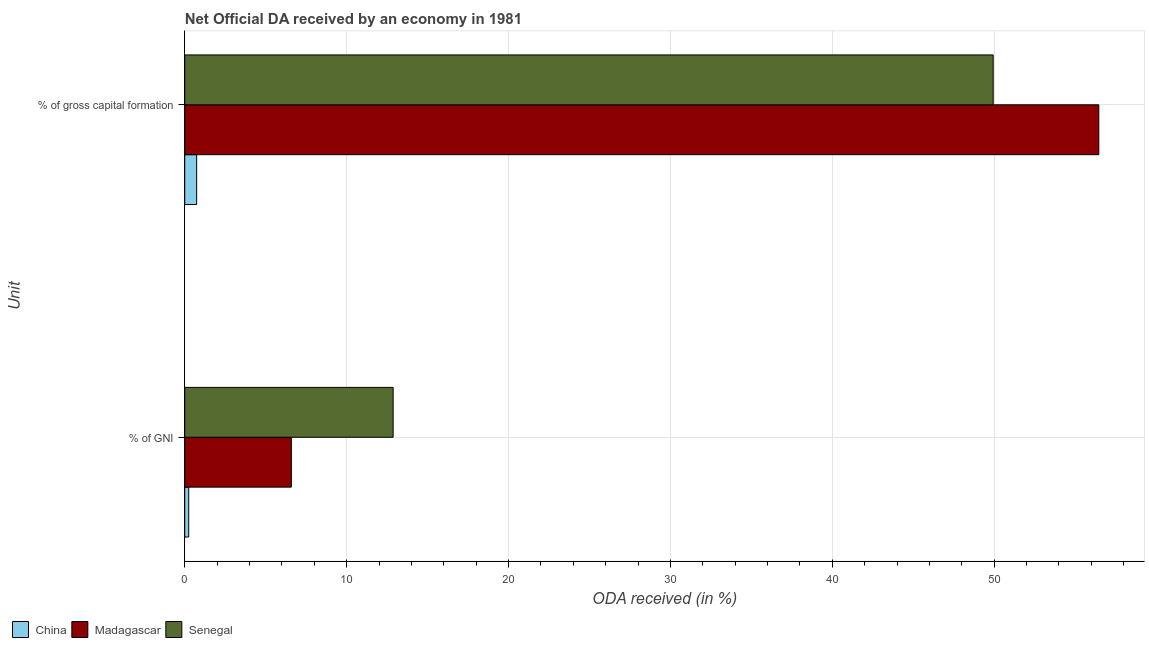What is the label of the 2nd group of bars from the top?
Your response must be concise. % of GNI. What is the oda received as percentage of gross capital formation in Madagascar?
Offer a very short reply. 56.46. Across all countries, what is the maximum oda received as percentage of gni?
Keep it short and to the point. 12.87. Across all countries, what is the minimum oda received as percentage of gni?
Provide a short and direct response. 0.24. In which country was the oda received as percentage of gross capital formation maximum?
Give a very brief answer. Madagascar. In which country was the oda received as percentage of gross capital formation minimum?
Your answer should be very brief. China. What is the total oda received as percentage of gross capital formation in the graph?
Provide a short and direct response. 107.14. What is the difference between the oda received as percentage of gni in China and that in Senegal?
Offer a terse response. -12.63. What is the difference between the oda received as percentage of gross capital formation in Senegal and the oda received as percentage of gni in China?
Your response must be concise. 49.69. What is the average oda received as percentage of gross capital formation per country?
Your response must be concise. 35.71. What is the difference between the oda received as percentage of gni and oda received as percentage of gross capital formation in Madagascar?
Give a very brief answer. -49.88. In how many countries, is the oda received as percentage of gni greater than 42 %?
Ensure brevity in your answer.  0. What is the ratio of the oda received as percentage of gni in Senegal to that in Madagascar?
Provide a short and direct response. 1.95. Is the oda received as percentage of gross capital formation in Madagascar less than that in Senegal?
Your response must be concise. No. In how many countries, is the oda received as percentage of gni greater than the average oda received as percentage of gni taken over all countries?
Keep it short and to the point. 2. What does the 3rd bar from the top in % of gross capital formation represents?
Your answer should be very brief. China. What does the 2nd bar from the bottom in % of GNI represents?
Make the answer very short. Madagascar. How many bars are there?
Make the answer very short. 6. How many countries are there in the graph?
Keep it short and to the point. 3. Does the graph contain any zero values?
Make the answer very short. No. Does the graph contain grids?
Offer a terse response. Yes. What is the title of the graph?
Your response must be concise. Net Official DA received by an economy in 1981. Does "Lithuania" appear as one of the legend labels in the graph?
Your answer should be very brief. No. What is the label or title of the X-axis?
Provide a short and direct response. ODA received (in %). What is the label or title of the Y-axis?
Your answer should be very brief. Unit. What is the ODA received (in %) in China in % of GNI?
Provide a short and direct response. 0.24. What is the ODA received (in %) of Madagascar in % of GNI?
Provide a short and direct response. 6.58. What is the ODA received (in %) of Senegal in % of GNI?
Your answer should be compact. 12.87. What is the ODA received (in %) in China in % of gross capital formation?
Offer a very short reply. 0.74. What is the ODA received (in %) in Madagascar in % of gross capital formation?
Provide a succinct answer. 56.46. What is the ODA received (in %) in Senegal in % of gross capital formation?
Your answer should be compact. 49.94. Across all Unit, what is the maximum ODA received (in %) in China?
Make the answer very short. 0.74. Across all Unit, what is the maximum ODA received (in %) in Madagascar?
Provide a short and direct response. 56.46. Across all Unit, what is the maximum ODA received (in %) of Senegal?
Make the answer very short. 49.94. Across all Unit, what is the minimum ODA received (in %) in China?
Make the answer very short. 0.24. Across all Unit, what is the minimum ODA received (in %) in Madagascar?
Provide a short and direct response. 6.58. Across all Unit, what is the minimum ODA received (in %) of Senegal?
Your answer should be compact. 12.87. What is the total ODA received (in %) of China in the graph?
Offer a very short reply. 0.98. What is the total ODA received (in %) in Madagascar in the graph?
Your answer should be very brief. 63.05. What is the total ODA received (in %) in Senegal in the graph?
Provide a succinct answer. 62.81. What is the difference between the ODA received (in %) of China in % of GNI and that in % of gross capital formation?
Offer a terse response. -0.49. What is the difference between the ODA received (in %) in Madagascar in % of GNI and that in % of gross capital formation?
Keep it short and to the point. -49.88. What is the difference between the ODA received (in %) in Senegal in % of GNI and that in % of gross capital formation?
Your response must be concise. -37.07. What is the difference between the ODA received (in %) in China in % of GNI and the ODA received (in %) in Madagascar in % of gross capital formation?
Keep it short and to the point. -56.22. What is the difference between the ODA received (in %) in China in % of GNI and the ODA received (in %) in Senegal in % of gross capital formation?
Keep it short and to the point. -49.69. What is the difference between the ODA received (in %) of Madagascar in % of GNI and the ODA received (in %) of Senegal in % of gross capital formation?
Offer a terse response. -43.35. What is the average ODA received (in %) in China per Unit?
Offer a very short reply. 0.49. What is the average ODA received (in %) in Madagascar per Unit?
Offer a very short reply. 31.52. What is the average ODA received (in %) in Senegal per Unit?
Offer a very short reply. 31.41. What is the difference between the ODA received (in %) of China and ODA received (in %) of Madagascar in % of GNI?
Your response must be concise. -6.34. What is the difference between the ODA received (in %) of China and ODA received (in %) of Senegal in % of GNI?
Make the answer very short. -12.63. What is the difference between the ODA received (in %) in Madagascar and ODA received (in %) in Senegal in % of GNI?
Keep it short and to the point. -6.29. What is the difference between the ODA received (in %) in China and ODA received (in %) in Madagascar in % of gross capital formation?
Your response must be concise. -55.73. What is the difference between the ODA received (in %) in China and ODA received (in %) in Senegal in % of gross capital formation?
Keep it short and to the point. -49.2. What is the difference between the ODA received (in %) in Madagascar and ODA received (in %) in Senegal in % of gross capital formation?
Your answer should be compact. 6.52. What is the ratio of the ODA received (in %) in China in % of GNI to that in % of gross capital formation?
Provide a succinct answer. 0.33. What is the ratio of the ODA received (in %) of Madagascar in % of GNI to that in % of gross capital formation?
Your answer should be very brief. 0.12. What is the ratio of the ODA received (in %) of Senegal in % of GNI to that in % of gross capital formation?
Offer a terse response. 0.26. What is the difference between the highest and the second highest ODA received (in %) in China?
Your answer should be very brief. 0.49. What is the difference between the highest and the second highest ODA received (in %) of Madagascar?
Offer a very short reply. 49.88. What is the difference between the highest and the second highest ODA received (in %) of Senegal?
Your response must be concise. 37.07. What is the difference between the highest and the lowest ODA received (in %) in China?
Ensure brevity in your answer.  0.49. What is the difference between the highest and the lowest ODA received (in %) of Madagascar?
Your answer should be compact. 49.88. What is the difference between the highest and the lowest ODA received (in %) of Senegal?
Keep it short and to the point. 37.07. 